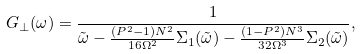Convert formula to latex. <formula><loc_0><loc_0><loc_500><loc_500>G _ { \perp } ( \omega ) = \frac { 1 } { \tilde { \omega } - \frac { ( P ^ { 2 } - 1 ) N ^ { 2 } } { 1 6 \Omega ^ { 2 } } \Sigma _ { 1 } ( \tilde { \omega } ) - \frac { ( 1 - P ^ { 2 } ) N ^ { 3 } } { 3 2 \Omega ^ { 3 } } \Sigma _ { 2 } ( \tilde { \omega } ) } ,</formula> 